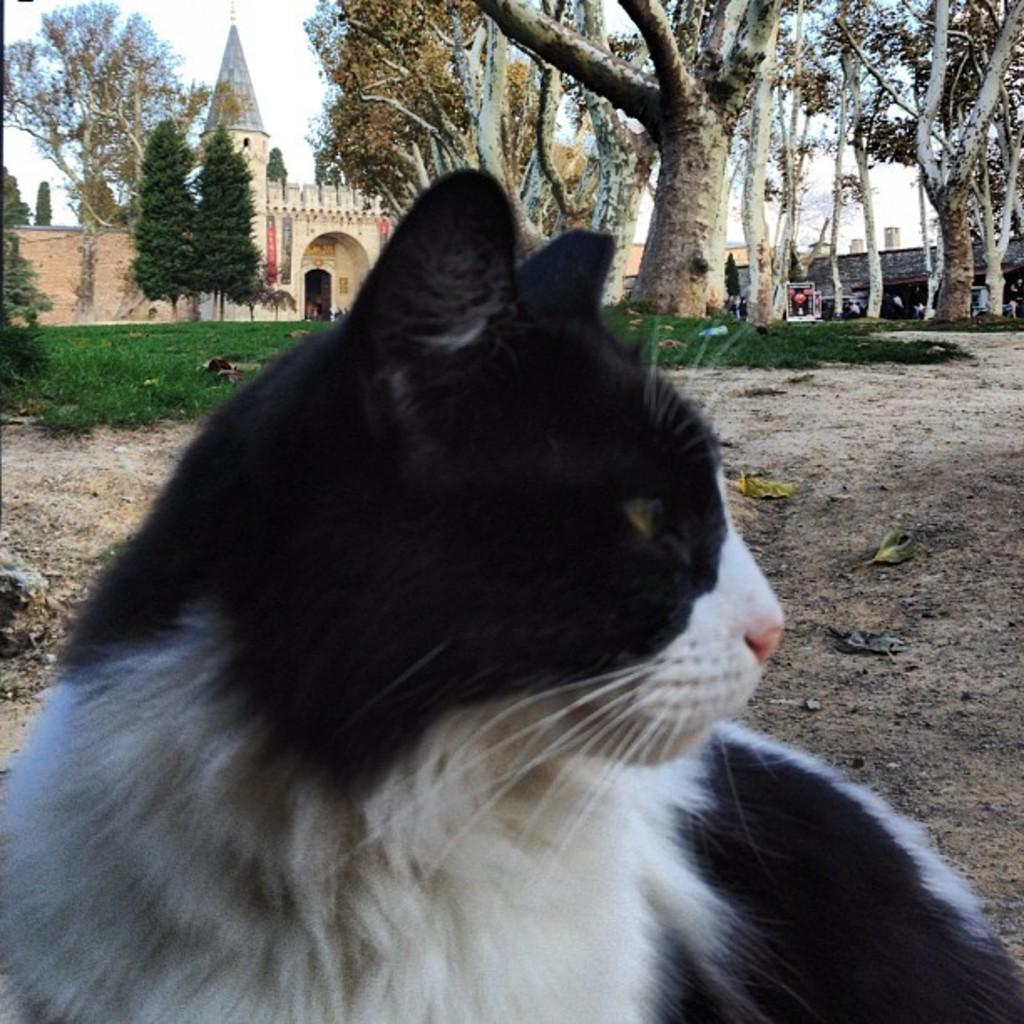What type of animal is in the image? There is a cat in the image. What colors can be seen on the cat? The cat has white and black colors. What can be seen in the background of the image? There are trees and a building in the background of the image. What color are the trees? The trees are green. What color is the building? The building has a cream color. What else is visible in the background of the image? The sky is visible in the background of the image. What color is the sky? The sky has a white color. What type of vegetable is being discussed by the committee in the image? There is no committee or vegetable present in the image; it features a cat with trees, a building, and the sky in the background. 